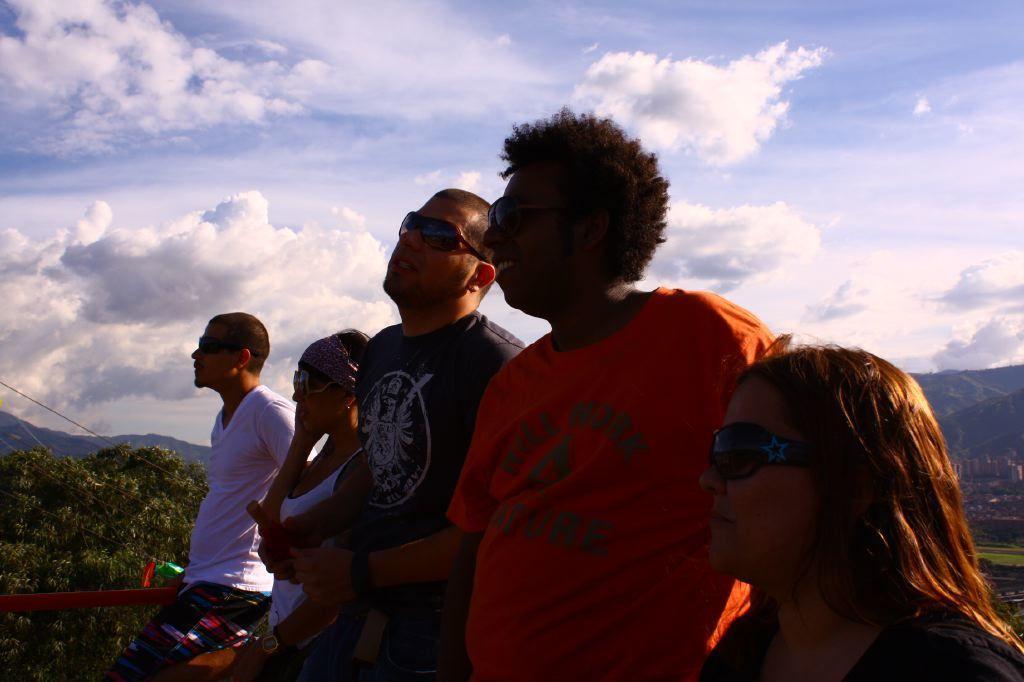Can you describe this image briefly? In this image there are three men and a two women standing. Behind them there are trees and mountains. At the top there is the sky. 